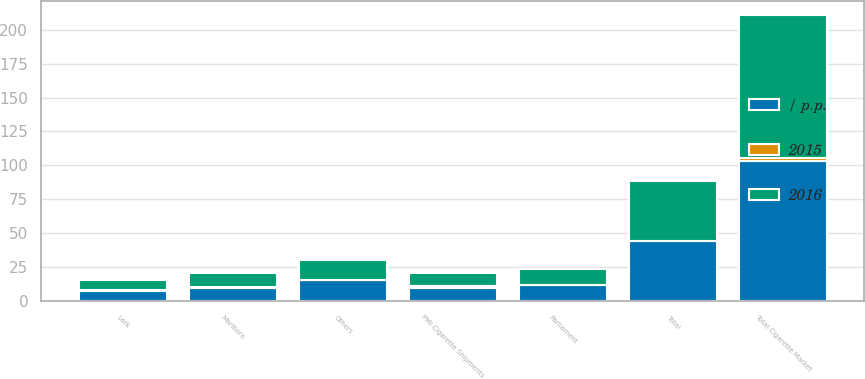Convert chart to OTSL. <chart><loc_0><loc_0><loc_500><loc_500><stacked_bar_chart><ecel><fcel>Total Cigarette Market<fcel>PMI Cigarette Shipments<fcel>Marlboro<fcel>Parliament<fcel>Lark<fcel>Others<fcel>Total<nl><fcel>2016<fcel>105.5<fcel>9.5<fcel>10.2<fcel>11.7<fcel>7.4<fcel>15<fcel>44.3<nl><fcel>/ p.p.<fcel>103.2<fcel>9.5<fcel>9.5<fcel>11.6<fcel>7.6<fcel>15.1<fcel>43.8<nl><fcel>2015<fcel>2.2<fcel>1.2<fcel>0.7<fcel>0.1<fcel>0.2<fcel>0.1<fcel>0.5<nl></chart> 